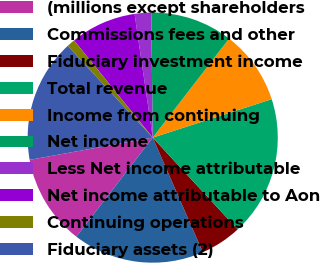Convert chart. <chart><loc_0><loc_0><loc_500><loc_500><pie_chart><fcel>(millions except shareholders<fcel>Commissions fees and other<fcel>Fiduciary investment income<fcel>Total revenue<fcel>Income from continuing<fcel>Net income<fcel>Less Net income attributable<fcel>Net income attributable to Aon<fcel>Continuing operations<fcel>Fiduciary assets (2)<nl><fcel>11.7%<fcel>17.02%<fcel>5.32%<fcel>18.09%<fcel>9.57%<fcel>10.64%<fcel>2.13%<fcel>8.51%<fcel>1.06%<fcel>15.96%<nl></chart> 